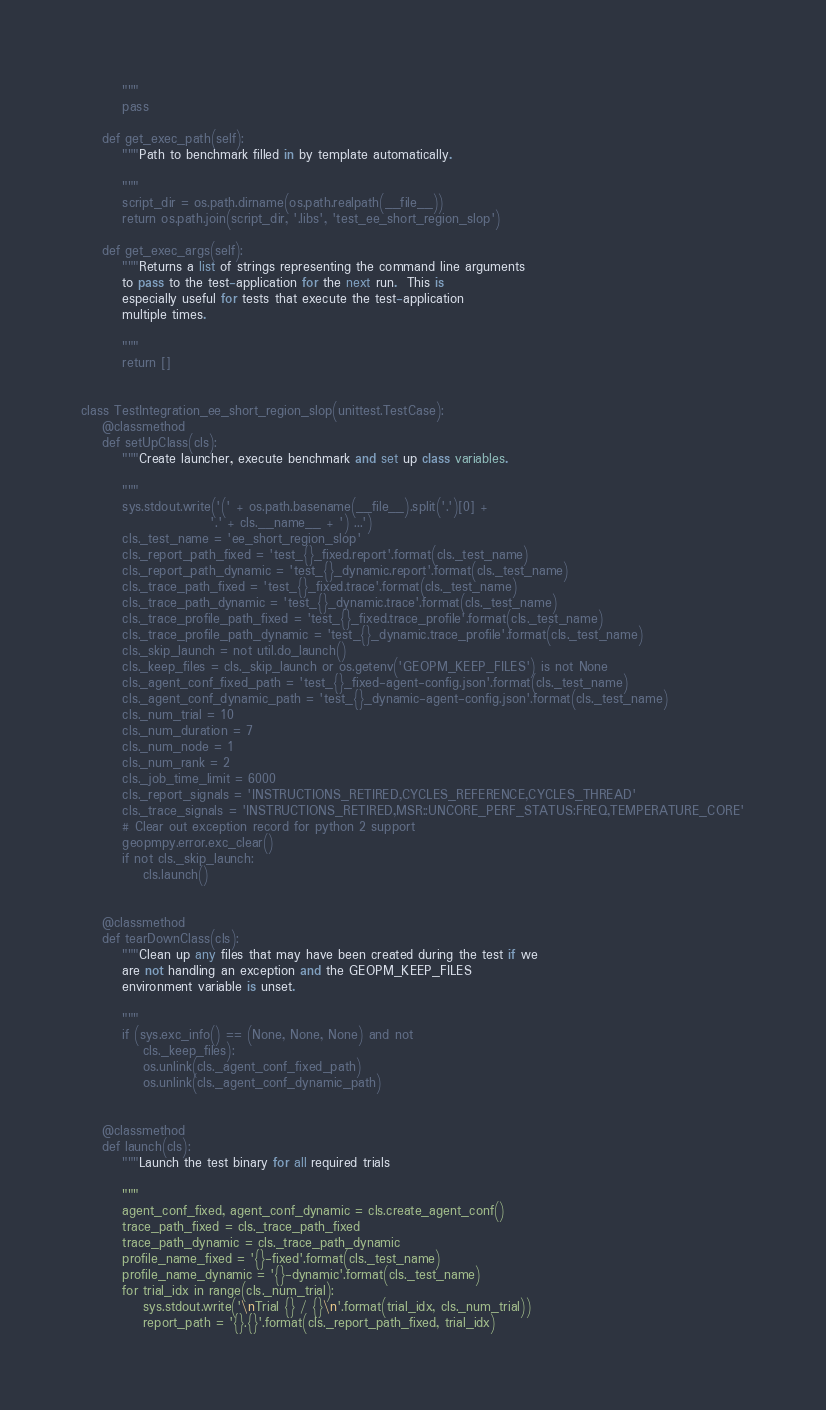<code> <loc_0><loc_0><loc_500><loc_500><_Python_>        """
        pass

    def get_exec_path(self):
        """Path to benchmark filled in by template automatically.

        """
        script_dir = os.path.dirname(os.path.realpath(__file__))
        return os.path.join(script_dir, '.libs', 'test_ee_short_region_slop')

    def get_exec_args(self):
        """Returns a list of strings representing the command line arguments
        to pass to the test-application for the next run.  This is
        especially useful for tests that execute the test-application
        multiple times.

        """
        return []


class TestIntegration_ee_short_region_slop(unittest.TestCase):
    @classmethod
    def setUpClass(cls):
        """Create launcher, execute benchmark and set up class variables.

        """
        sys.stdout.write('(' + os.path.basename(__file__).split('.')[0] +
                         '.' + cls.__name__ + ') ...')
        cls._test_name = 'ee_short_region_slop'
        cls._report_path_fixed = 'test_{}_fixed.report'.format(cls._test_name)
        cls._report_path_dynamic = 'test_{}_dynamic.report'.format(cls._test_name)
        cls._trace_path_fixed = 'test_{}_fixed.trace'.format(cls._test_name)
        cls._trace_path_dynamic = 'test_{}_dynamic.trace'.format(cls._test_name)
        cls._trace_profile_path_fixed = 'test_{}_fixed.trace_profile'.format(cls._test_name)
        cls._trace_profile_path_dynamic = 'test_{}_dynamic.trace_profile'.format(cls._test_name)
        cls._skip_launch = not util.do_launch()
        cls._keep_files = cls._skip_launch or os.getenv('GEOPM_KEEP_FILES') is not None
        cls._agent_conf_fixed_path = 'test_{}_fixed-agent-config.json'.format(cls._test_name)
        cls._agent_conf_dynamic_path = 'test_{}_dynamic-agent-config.json'.format(cls._test_name)
        cls._num_trial = 10
        cls._num_duration = 7
        cls._num_node = 1
        cls._num_rank = 2
        cls._job_time_limit = 6000
        cls._report_signals = 'INSTRUCTIONS_RETIRED,CYCLES_REFERENCE,CYCLES_THREAD'
        cls._trace_signals = 'INSTRUCTIONS_RETIRED,MSR::UNCORE_PERF_STATUS:FREQ,TEMPERATURE_CORE'
        # Clear out exception record for python 2 support
        geopmpy.error.exc_clear()
        if not cls._skip_launch:
            cls.launch()


    @classmethod
    def tearDownClass(cls):
        """Clean up any files that may have been created during the test if we
        are not handling an exception and the GEOPM_KEEP_FILES
        environment variable is unset.

        """
        if (sys.exc_info() == (None, None, None) and not
            cls._keep_files):
            os.unlink(cls._agent_conf_fixed_path)
            os.unlink(cls._agent_conf_dynamic_path)


    @classmethod
    def launch(cls):
        """Launch the test binary for all required trials

        """
        agent_conf_fixed, agent_conf_dynamic = cls.create_agent_conf()
        trace_path_fixed = cls._trace_path_fixed
        trace_path_dynamic = cls._trace_path_dynamic
        profile_name_fixed = '{}-fixed'.format(cls._test_name)
        profile_name_dynamic = '{}-dynamic'.format(cls._test_name)
        for trial_idx in range(cls._num_trial):
            sys.stdout.write('\nTrial {} / {}\n'.format(trial_idx, cls._num_trial))
            report_path = '{}.{}'.format(cls._report_path_fixed, trial_idx)</code> 